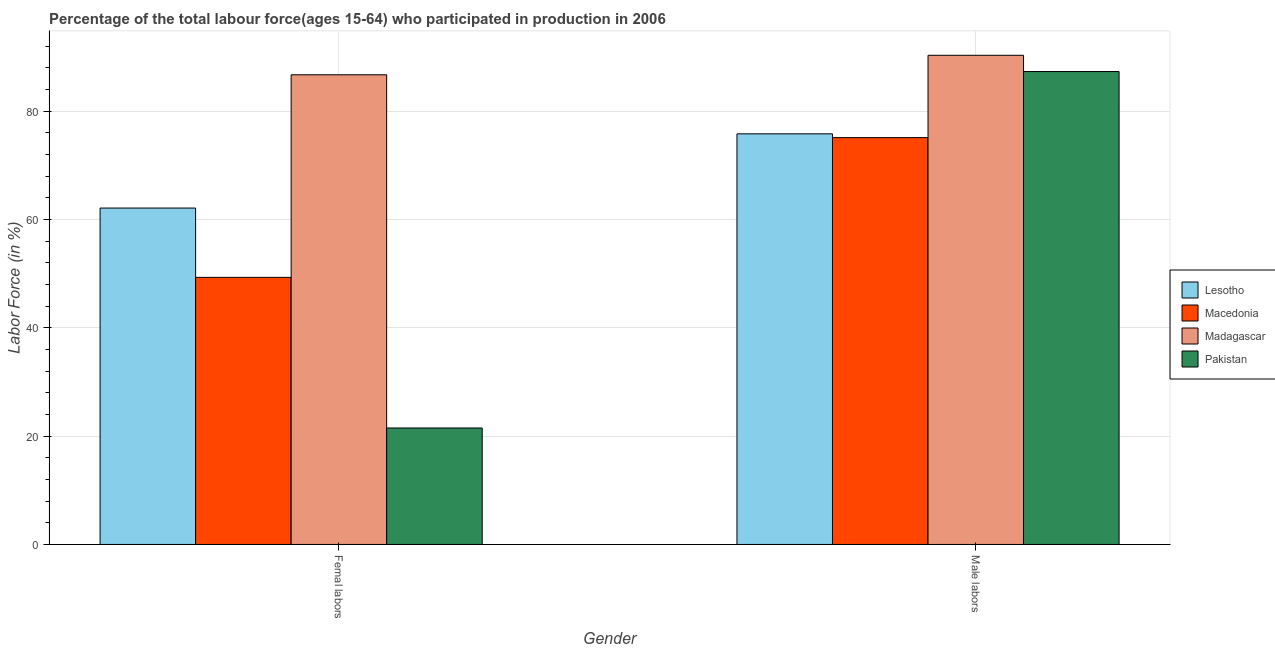How many groups of bars are there?
Make the answer very short. 2. Are the number of bars per tick equal to the number of legend labels?
Ensure brevity in your answer.  Yes. Are the number of bars on each tick of the X-axis equal?
Your response must be concise. Yes. What is the label of the 1st group of bars from the left?
Provide a succinct answer. Femal labors. What is the percentage of female labor force in Madagascar?
Your response must be concise. 86.7. Across all countries, what is the maximum percentage of female labor force?
Ensure brevity in your answer.  86.7. In which country was the percentage of female labor force maximum?
Give a very brief answer. Madagascar. In which country was the percentage of male labour force minimum?
Ensure brevity in your answer.  Macedonia. What is the total percentage of male labour force in the graph?
Offer a terse response. 328.5. What is the difference between the percentage of male labour force in Lesotho and that in Pakistan?
Provide a succinct answer. -11.5. What is the difference between the percentage of female labor force in Lesotho and the percentage of male labour force in Macedonia?
Your response must be concise. -13. What is the average percentage of female labor force per country?
Your answer should be very brief. 54.9. What is the difference between the percentage of male labour force and percentage of female labor force in Macedonia?
Make the answer very short. 25.8. In how many countries, is the percentage of male labour force greater than 8 %?
Ensure brevity in your answer.  4. What is the ratio of the percentage of male labour force in Macedonia to that in Lesotho?
Offer a very short reply. 0.99. Is the percentage of female labor force in Lesotho less than that in Macedonia?
Your answer should be compact. No. In how many countries, is the percentage of male labour force greater than the average percentage of male labour force taken over all countries?
Offer a very short reply. 2. What does the 1st bar from the left in Male labors represents?
Offer a terse response. Lesotho. What does the 4th bar from the right in Male labors represents?
Keep it short and to the point. Lesotho. How many bars are there?
Offer a very short reply. 8. Are all the bars in the graph horizontal?
Offer a very short reply. No. Does the graph contain any zero values?
Ensure brevity in your answer.  No. Does the graph contain grids?
Provide a short and direct response. Yes. How are the legend labels stacked?
Your answer should be compact. Vertical. What is the title of the graph?
Offer a very short reply. Percentage of the total labour force(ages 15-64) who participated in production in 2006. What is the label or title of the Y-axis?
Provide a short and direct response. Labor Force (in %). What is the Labor Force (in %) of Lesotho in Femal labors?
Your answer should be compact. 62.1. What is the Labor Force (in %) of Macedonia in Femal labors?
Give a very brief answer. 49.3. What is the Labor Force (in %) in Madagascar in Femal labors?
Offer a very short reply. 86.7. What is the Labor Force (in %) of Pakistan in Femal labors?
Ensure brevity in your answer.  21.5. What is the Labor Force (in %) in Lesotho in Male labors?
Provide a succinct answer. 75.8. What is the Labor Force (in %) of Macedonia in Male labors?
Keep it short and to the point. 75.1. What is the Labor Force (in %) of Madagascar in Male labors?
Provide a short and direct response. 90.3. What is the Labor Force (in %) in Pakistan in Male labors?
Provide a short and direct response. 87.3. Across all Gender, what is the maximum Labor Force (in %) in Lesotho?
Ensure brevity in your answer.  75.8. Across all Gender, what is the maximum Labor Force (in %) of Macedonia?
Your answer should be very brief. 75.1. Across all Gender, what is the maximum Labor Force (in %) in Madagascar?
Provide a short and direct response. 90.3. Across all Gender, what is the maximum Labor Force (in %) in Pakistan?
Give a very brief answer. 87.3. Across all Gender, what is the minimum Labor Force (in %) in Lesotho?
Your response must be concise. 62.1. Across all Gender, what is the minimum Labor Force (in %) in Macedonia?
Offer a terse response. 49.3. Across all Gender, what is the minimum Labor Force (in %) of Madagascar?
Your answer should be very brief. 86.7. What is the total Labor Force (in %) in Lesotho in the graph?
Offer a terse response. 137.9. What is the total Labor Force (in %) in Macedonia in the graph?
Provide a succinct answer. 124.4. What is the total Labor Force (in %) in Madagascar in the graph?
Your answer should be very brief. 177. What is the total Labor Force (in %) of Pakistan in the graph?
Keep it short and to the point. 108.8. What is the difference between the Labor Force (in %) of Lesotho in Femal labors and that in Male labors?
Provide a succinct answer. -13.7. What is the difference between the Labor Force (in %) of Macedonia in Femal labors and that in Male labors?
Your response must be concise. -25.8. What is the difference between the Labor Force (in %) in Pakistan in Femal labors and that in Male labors?
Give a very brief answer. -65.8. What is the difference between the Labor Force (in %) of Lesotho in Femal labors and the Labor Force (in %) of Madagascar in Male labors?
Offer a very short reply. -28.2. What is the difference between the Labor Force (in %) in Lesotho in Femal labors and the Labor Force (in %) in Pakistan in Male labors?
Provide a short and direct response. -25.2. What is the difference between the Labor Force (in %) of Macedonia in Femal labors and the Labor Force (in %) of Madagascar in Male labors?
Provide a succinct answer. -41. What is the difference between the Labor Force (in %) in Macedonia in Femal labors and the Labor Force (in %) in Pakistan in Male labors?
Give a very brief answer. -38. What is the difference between the Labor Force (in %) of Madagascar in Femal labors and the Labor Force (in %) of Pakistan in Male labors?
Your answer should be compact. -0.6. What is the average Labor Force (in %) in Lesotho per Gender?
Give a very brief answer. 68.95. What is the average Labor Force (in %) of Macedonia per Gender?
Your answer should be very brief. 62.2. What is the average Labor Force (in %) in Madagascar per Gender?
Ensure brevity in your answer.  88.5. What is the average Labor Force (in %) of Pakistan per Gender?
Give a very brief answer. 54.4. What is the difference between the Labor Force (in %) in Lesotho and Labor Force (in %) in Macedonia in Femal labors?
Your answer should be very brief. 12.8. What is the difference between the Labor Force (in %) of Lesotho and Labor Force (in %) of Madagascar in Femal labors?
Keep it short and to the point. -24.6. What is the difference between the Labor Force (in %) in Lesotho and Labor Force (in %) in Pakistan in Femal labors?
Provide a succinct answer. 40.6. What is the difference between the Labor Force (in %) of Macedonia and Labor Force (in %) of Madagascar in Femal labors?
Ensure brevity in your answer.  -37.4. What is the difference between the Labor Force (in %) in Macedonia and Labor Force (in %) in Pakistan in Femal labors?
Your response must be concise. 27.8. What is the difference between the Labor Force (in %) of Madagascar and Labor Force (in %) of Pakistan in Femal labors?
Offer a very short reply. 65.2. What is the difference between the Labor Force (in %) in Lesotho and Labor Force (in %) in Macedonia in Male labors?
Your answer should be compact. 0.7. What is the difference between the Labor Force (in %) in Macedonia and Labor Force (in %) in Madagascar in Male labors?
Your answer should be very brief. -15.2. What is the difference between the Labor Force (in %) in Madagascar and Labor Force (in %) in Pakistan in Male labors?
Keep it short and to the point. 3. What is the ratio of the Labor Force (in %) of Lesotho in Femal labors to that in Male labors?
Offer a very short reply. 0.82. What is the ratio of the Labor Force (in %) of Macedonia in Femal labors to that in Male labors?
Give a very brief answer. 0.66. What is the ratio of the Labor Force (in %) in Madagascar in Femal labors to that in Male labors?
Your answer should be compact. 0.96. What is the ratio of the Labor Force (in %) of Pakistan in Femal labors to that in Male labors?
Make the answer very short. 0.25. What is the difference between the highest and the second highest Labor Force (in %) in Macedonia?
Your answer should be very brief. 25.8. What is the difference between the highest and the second highest Labor Force (in %) in Madagascar?
Provide a short and direct response. 3.6. What is the difference between the highest and the second highest Labor Force (in %) in Pakistan?
Give a very brief answer. 65.8. What is the difference between the highest and the lowest Labor Force (in %) in Lesotho?
Your answer should be very brief. 13.7. What is the difference between the highest and the lowest Labor Force (in %) in Macedonia?
Provide a succinct answer. 25.8. What is the difference between the highest and the lowest Labor Force (in %) of Madagascar?
Your answer should be very brief. 3.6. What is the difference between the highest and the lowest Labor Force (in %) in Pakistan?
Ensure brevity in your answer.  65.8. 